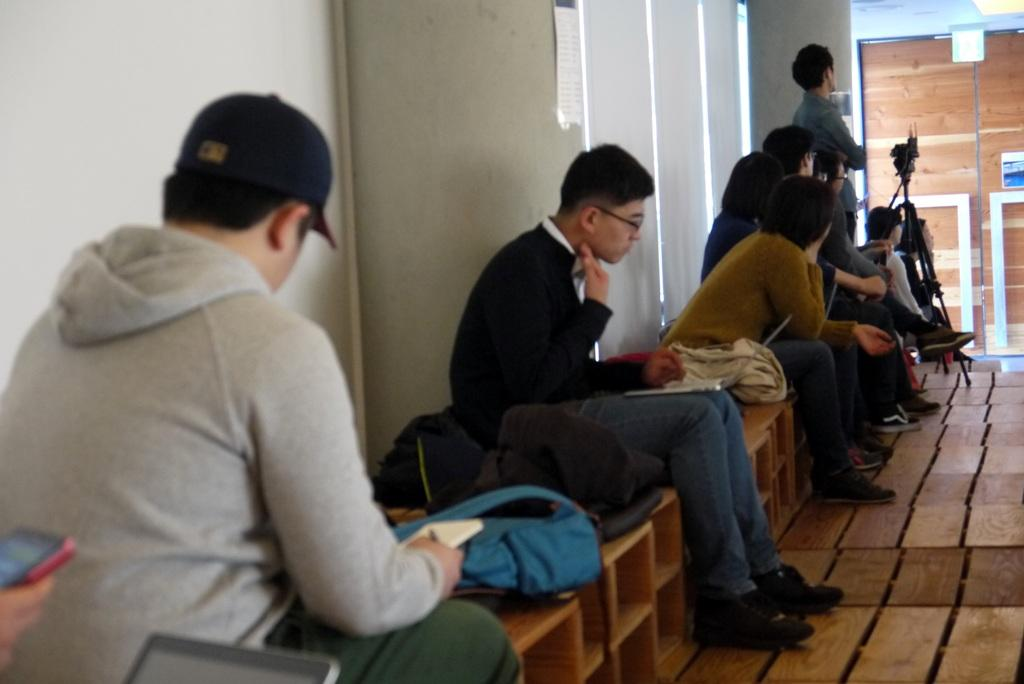What are the people in the image doing? The persons in the image are sitting on the benches. What can be seen in the background of the image? There is a wall, a camera, a camera stand, and a light in the background of the image. What direction is the mass moving in the image? There is no mass present in the image, so it cannot be determined which direction it would move. 